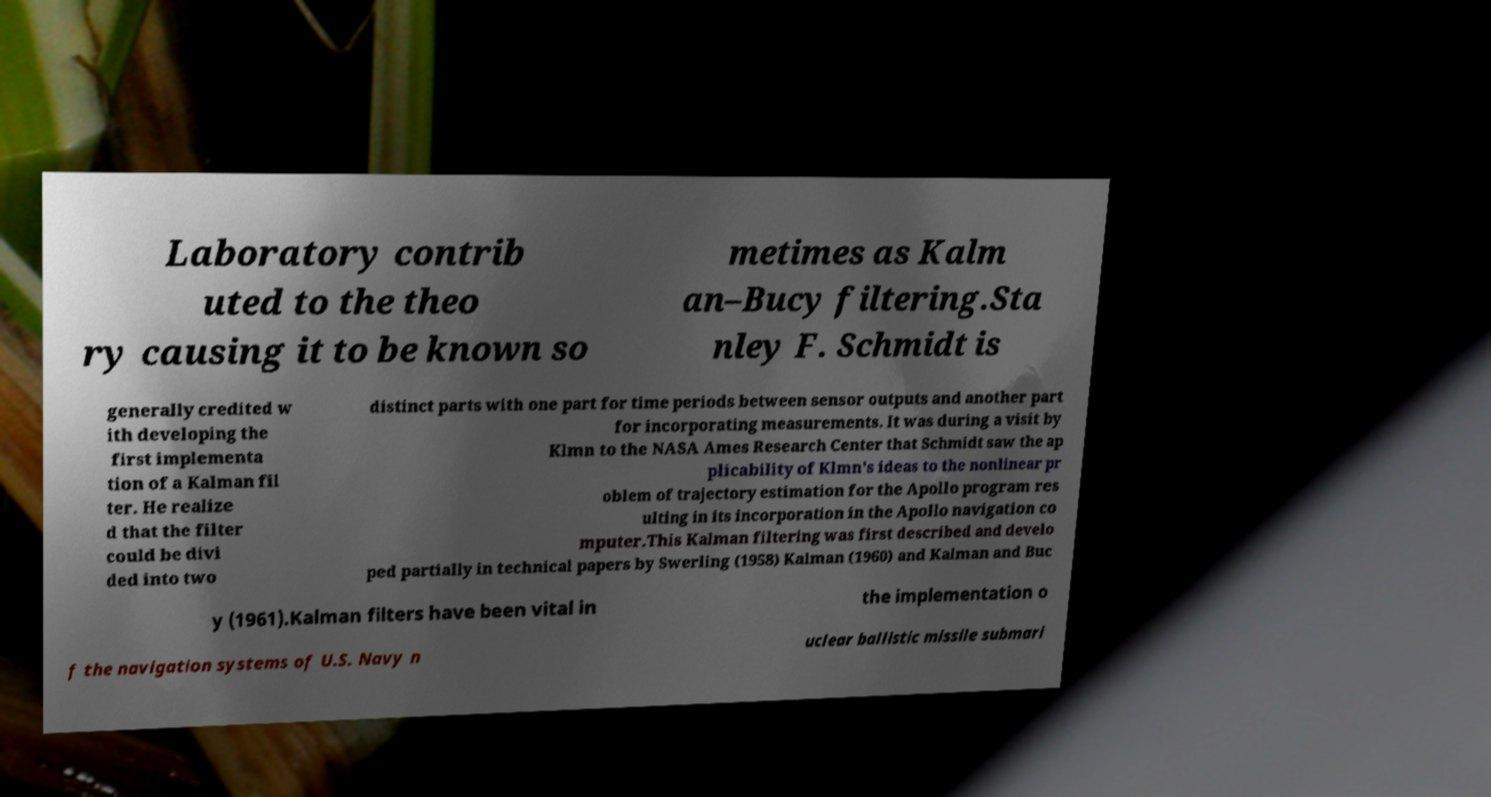Can you read and provide the text displayed in the image?This photo seems to have some interesting text. Can you extract and type it out for me? Laboratory contrib uted to the theo ry causing it to be known so metimes as Kalm an–Bucy filtering.Sta nley F. Schmidt is generally credited w ith developing the first implementa tion of a Kalman fil ter. He realize d that the filter could be divi ded into two distinct parts with one part for time periods between sensor outputs and another part for incorporating measurements. It was during a visit by Klmn to the NASA Ames Research Center that Schmidt saw the ap plicability of Klmn's ideas to the nonlinear pr oblem of trajectory estimation for the Apollo program res ulting in its incorporation in the Apollo navigation co mputer.This Kalman filtering was first described and develo ped partially in technical papers by Swerling (1958) Kalman (1960) and Kalman and Buc y (1961).Kalman filters have been vital in the implementation o f the navigation systems of U.S. Navy n uclear ballistic missile submari 